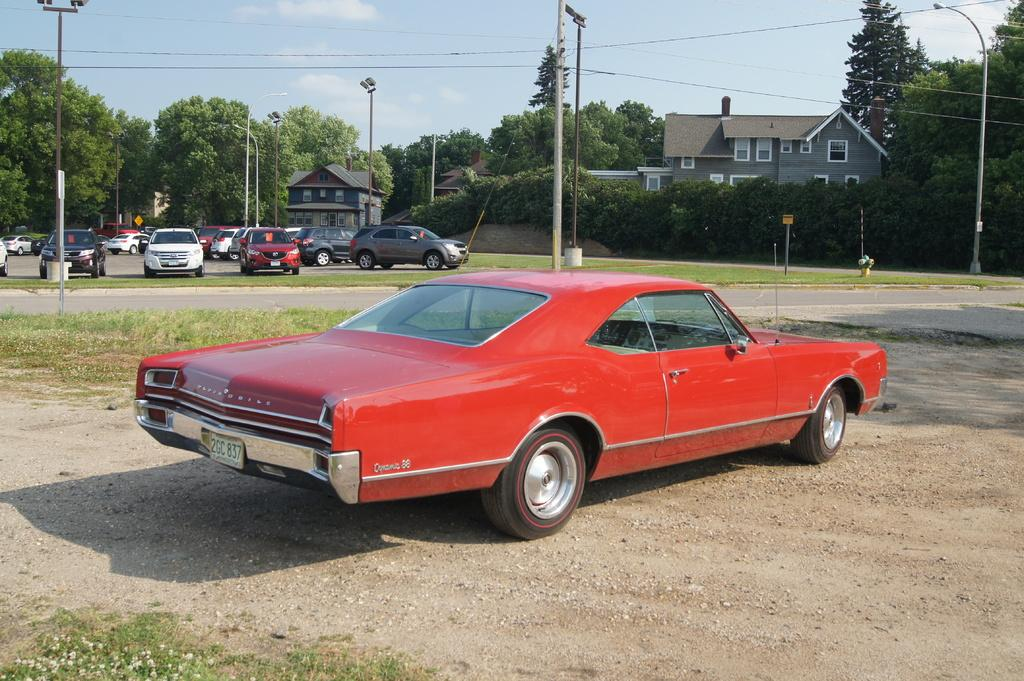What types of objects can be seen in the image? There are vehicles, poles, lights, cables, buildings, trees, and the sky is visible in the background of the image. Can you describe the poles in the image? The poles are likely supporting the cables and lights in the image. What type of structures are visible in the image? There are buildings in the image. What is the natural element present in the image? Trees are the natural element present in the image. Can you tell me how many ladybugs are crawling on the buildings in the image? There are no ladybugs present in the image; it features vehicles, poles, lights, cables, buildings, trees, and the sky. What type of curtain can be seen hanging from the buildings in the image? There are no curtains visible in the image; it only shows vehicles, poles, lights, cables, buildings, trees, and the sky. 